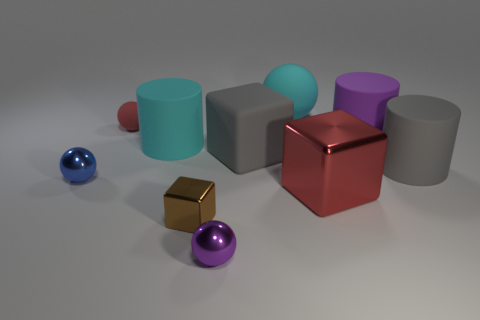Is there a large cylinder of the same color as the big ball?
Keep it short and to the point. Yes. There is a tiny object that is behind the big gray block; is it the same color as the block behind the large gray matte cylinder?
Offer a very short reply. No. There is a large cyan object that is behind the purple matte cylinder; what material is it?
Ensure brevity in your answer.  Rubber. There is another ball that is made of the same material as the small blue sphere; what is its color?
Provide a short and direct response. Purple. What number of cubes have the same size as the purple ball?
Provide a succinct answer. 1. There is a purple thing behind the gray block; is it the same size as the tiny red object?
Provide a succinct answer. No. There is a thing that is both right of the cyan matte ball and to the left of the large purple cylinder; what shape is it?
Offer a terse response. Cube. Are there any tiny spheres right of the tiny brown cube?
Your answer should be very brief. Yes. Is the brown metallic object the same shape as the red metal thing?
Provide a succinct answer. Yes. Are there the same number of cyan matte objects that are to the right of the rubber cube and large cyan rubber things in front of the big gray cylinder?
Your response must be concise. No. 